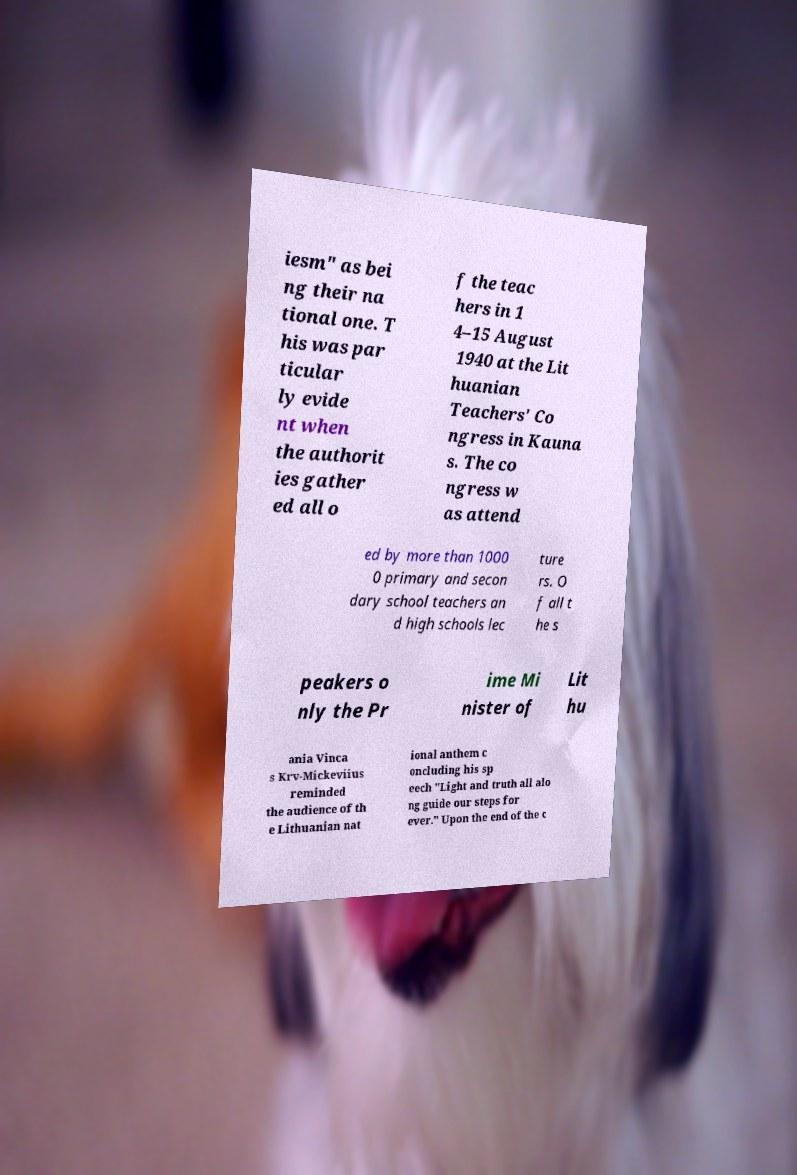Could you assist in decoding the text presented in this image and type it out clearly? iesm" as bei ng their na tional one. T his was par ticular ly evide nt when the authorit ies gather ed all o f the teac hers in 1 4–15 August 1940 at the Lit huanian Teachers' Co ngress in Kauna s. The co ngress w as attend ed by more than 1000 0 primary and secon dary school teachers an d high schools lec ture rs. O f all t he s peakers o nly the Pr ime Mi nister of Lit hu ania Vinca s Krv-Mickeviius reminded the audience of th e Lithuanian nat ional anthem c oncluding his sp eech "Light and truth all alo ng guide our steps for ever." Upon the end of the c 